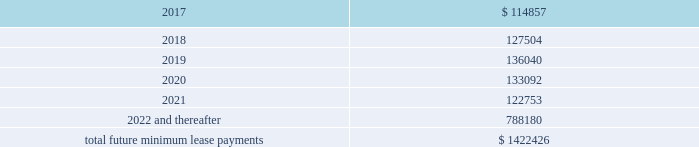Interest expense , net was $ 26.4 million , $ 14.6 million , and $ 5.3 million for the years ended december 31 , 2016 , 2015 and 2014 , respectively .
Interest expense includes the amortization of deferred financing costs , bank fees , capital and built-to-suit lease interest and interest expense under the credit and other long term debt facilities .
Amortization of deferred financing costs was $ 1.2 million , $ 0.8 million , and $ 0.6 million for the years ended december 31 , 2016 , 2015 and 2014 , respectively .
The company monitors the financial health and stability of its lenders under the credit and other long term debt facilities , however during any period of significant instability in the credit markets lenders could be negatively impacted in their ability to perform under these facilities .
Commitments and contingencies obligations under operating leases the company leases warehouse space , office facilities , space for its brand and factory house stores and certain equipment under non-cancelable operating leases .
The leases expire at various dates through 2033 , excluding extensions at the company 2019s option , and include provisions for rental adjustments .
The table below includes executed lease agreements for brand and factory house stores that the company did not yet occupy as of december 31 , 2016 and does not include contingent rent the company may incur at its stores based on future sales above a specified minimum or payments made for maintenance , insurance and real estate taxes .
The following is a schedule of future minimum lease payments for non-cancelable real property operating leases as of december 31 , 2016 as well as significant operating lease agreements entered into during the period after december 31 , 2016 through the date of this report : ( in thousands ) .
Included in selling , general and administrative expense was rent expense of $ 109.0 million , $ 83.0 million and $ 59.0 million for the years ended december 31 , 2016 , 2015 and 2014 , respectively , under non-cancelable operating lease agreements .
Included in these amounts was contingent rent expense of $ 13.0 million , $ 11.0 million and $ 11.0 million for the years ended december 31 , 2016 , 2015 and 2014 , respectively .
Sports marketing and other commitments within the normal course of business , the company enters into contractual commitments in order to promote the company 2019s brand and products .
These commitments include sponsorship agreements with teams and athletes on the collegiate and professional levels , official supplier agreements , athletic event sponsorships and other marketing commitments .
The following is a schedule of the company 2019s future minimum payments under its sponsorship and other marketing agreements as of december 31 .
What is the percentage change in interest expense from 2015 to 2016? 
Computations: ((26.4 - 14.6) / 14.6)
Answer: 0.80822. 